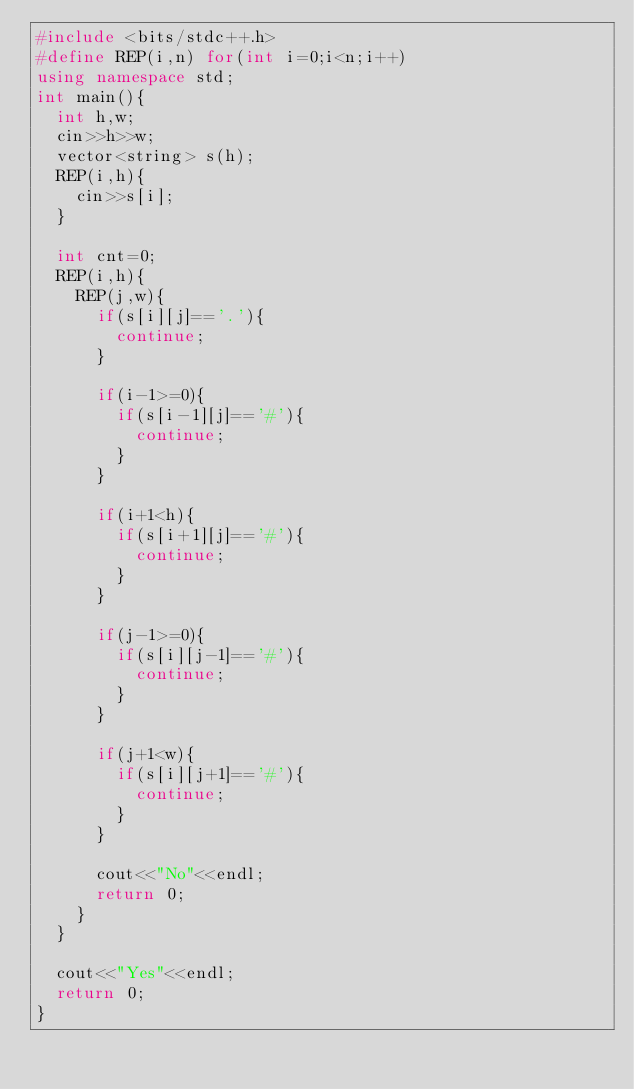<code> <loc_0><loc_0><loc_500><loc_500><_C++_>#include <bits/stdc++.h>
#define REP(i,n) for(int i=0;i<n;i++)
using namespace std;
int main(){
  int h,w;
  cin>>h>>w;
  vector<string> s(h);
  REP(i,h){
    cin>>s[i];
  }
  
  int cnt=0;
  REP(i,h){
    REP(j,w){
      if(s[i][j]=='.'){
        continue;
      }
      
      if(i-1>=0){
        if(s[i-1][j]=='#'){
          continue;
        }
      }
      
      if(i+1<h){
        if(s[i+1][j]=='#'){
          continue;
        }
      }
      
      if(j-1>=0){
        if(s[i][j-1]=='#'){
          continue;
        }
      }
      
      if(j+1<w){
        if(s[i][j+1]=='#'){
          continue;
        }
      }
      
      cout<<"No"<<endl;
      return 0;
    }
  }
  
  cout<<"Yes"<<endl;
  return 0;
}</code> 